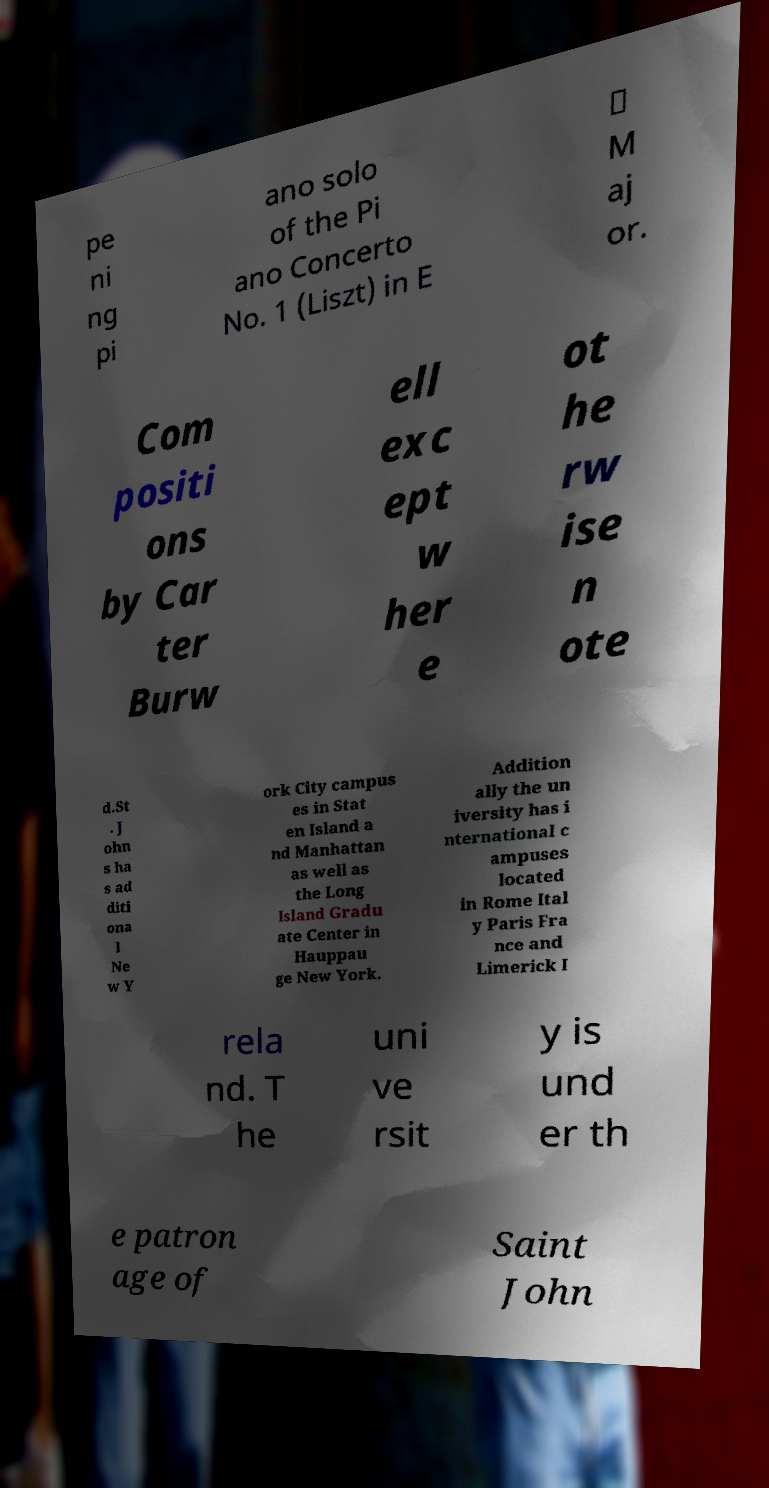I need the written content from this picture converted into text. Can you do that? pe ni ng pi ano solo of the Pi ano Concerto No. 1 (Liszt) in E ♭ M aj or. Com positi ons by Car ter Burw ell exc ept w her e ot he rw ise n ote d.St . J ohn s ha s ad diti ona l Ne w Y ork City campus es in Stat en Island a nd Manhattan as well as the Long Island Gradu ate Center in Hauppau ge New York. Addition ally the un iversity has i nternational c ampuses located in Rome Ital y Paris Fra nce and Limerick I rela nd. T he uni ve rsit y is und er th e patron age of Saint John 